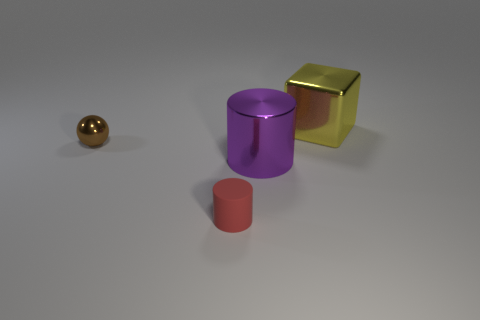Add 2 purple objects. How many objects exist? 6 Add 2 large cyan things. How many large cyan things exist? 2 Subtract 0 gray spheres. How many objects are left? 4 Subtract all tiny gray matte blocks. Subtract all brown shiny objects. How many objects are left? 3 Add 4 yellow blocks. How many yellow blocks are left? 5 